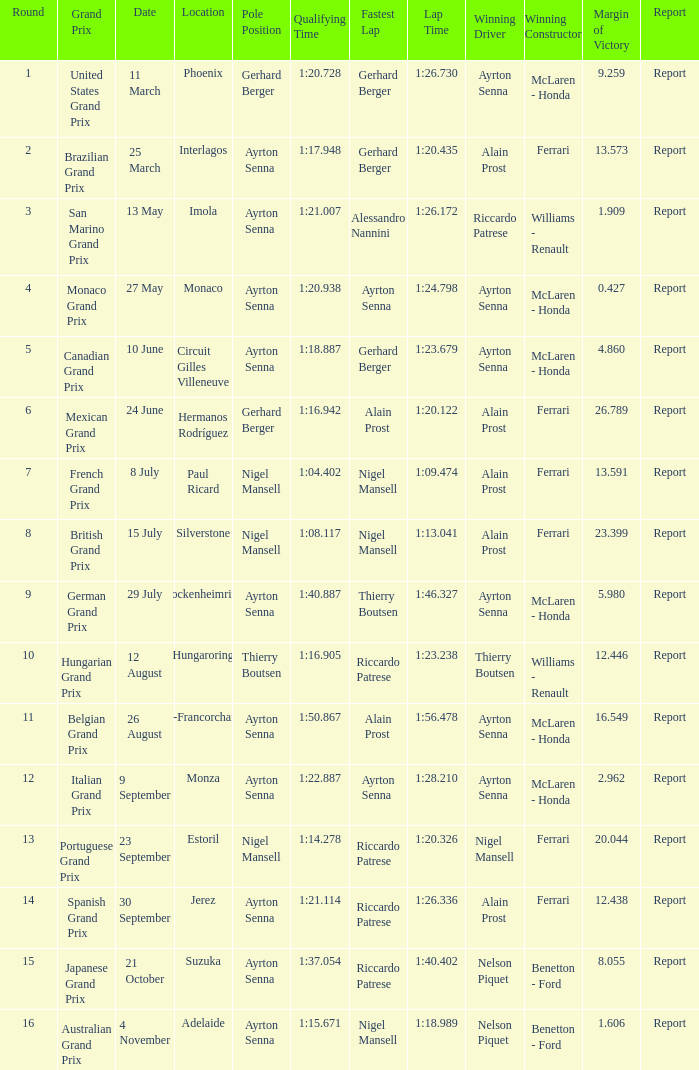What is the date that Ayrton Senna was the drive in Monza? 9 September. 